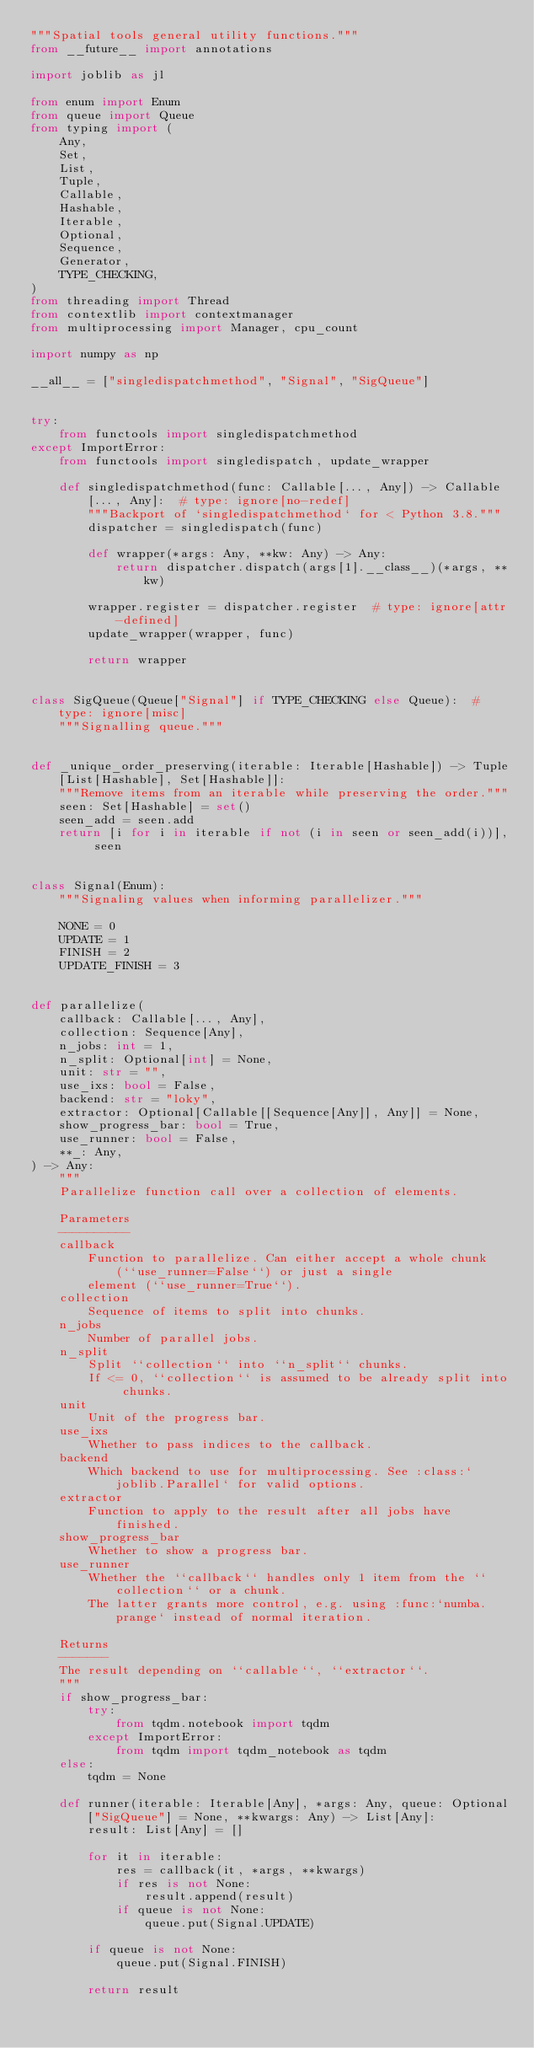<code> <loc_0><loc_0><loc_500><loc_500><_Python_>"""Spatial tools general utility functions."""
from __future__ import annotations

import joblib as jl

from enum import Enum
from queue import Queue
from typing import (
    Any,
    Set,
    List,
    Tuple,
    Callable,
    Hashable,
    Iterable,
    Optional,
    Sequence,
    Generator,
    TYPE_CHECKING,
)
from threading import Thread
from contextlib import contextmanager
from multiprocessing import Manager, cpu_count

import numpy as np

__all__ = ["singledispatchmethod", "Signal", "SigQueue"]


try:
    from functools import singledispatchmethod
except ImportError:
    from functools import singledispatch, update_wrapper

    def singledispatchmethod(func: Callable[..., Any]) -> Callable[..., Any]:  # type: ignore[no-redef]
        """Backport of `singledispatchmethod` for < Python 3.8."""
        dispatcher = singledispatch(func)

        def wrapper(*args: Any, **kw: Any) -> Any:
            return dispatcher.dispatch(args[1].__class__)(*args, **kw)

        wrapper.register = dispatcher.register  # type: ignore[attr-defined]
        update_wrapper(wrapper, func)

        return wrapper


class SigQueue(Queue["Signal"] if TYPE_CHECKING else Queue):  # type: ignore[misc]
    """Signalling queue."""


def _unique_order_preserving(iterable: Iterable[Hashable]) -> Tuple[List[Hashable], Set[Hashable]]:
    """Remove items from an iterable while preserving the order."""
    seen: Set[Hashable] = set()
    seen_add = seen.add
    return [i for i in iterable if not (i in seen or seen_add(i))], seen


class Signal(Enum):
    """Signaling values when informing parallelizer."""

    NONE = 0
    UPDATE = 1
    FINISH = 2
    UPDATE_FINISH = 3


def parallelize(
    callback: Callable[..., Any],
    collection: Sequence[Any],
    n_jobs: int = 1,
    n_split: Optional[int] = None,
    unit: str = "",
    use_ixs: bool = False,
    backend: str = "loky",
    extractor: Optional[Callable[[Sequence[Any]], Any]] = None,
    show_progress_bar: bool = True,
    use_runner: bool = False,
    **_: Any,
) -> Any:
    """
    Parallelize function call over a collection of elements.

    Parameters
    ----------
    callback
        Function to parallelize. Can either accept a whole chunk (``use_runner=False``) or just a single
        element (``use_runner=True``).
    collection
        Sequence of items to split into chunks.
    n_jobs
        Number of parallel jobs.
    n_split
        Split ``collection`` into ``n_split`` chunks.
        If <= 0, ``collection`` is assumed to be already split into chunks.
    unit
        Unit of the progress bar.
    use_ixs
        Whether to pass indices to the callback.
    backend
        Which backend to use for multiprocessing. See :class:`joblib.Parallel` for valid options.
    extractor
        Function to apply to the result after all jobs have finished.
    show_progress_bar
        Whether to show a progress bar.
    use_runner
        Whether the ``callback`` handles only 1 item from the ``collection`` or a chunk.
        The latter grants more control, e.g. using :func:`numba.prange` instead of normal iteration.

    Returns
    -------
    The result depending on ``callable``, ``extractor``.
    """
    if show_progress_bar:
        try:
            from tqdm.notebook import tqdm
        except ImportError:
            from tqdm import tqdm_notebook as tqdm
    else:
        tqdm = None

    def runner(iterable: Iterable[Any], *args: Any, queue: Optional["SigQueue"] = None, **kwargs: Any) -> List[Any]:
        result: List[Any] = []

        for it in iterable:
            res = callback(it, *args, **kwargs)
            if res is not None:
                result.append(result)
            if queue is not None:
                queue.put(Signal.UPDATE)

        if queue is not None:
            queue.put(Signal.FINISH)

        return result
</code> 